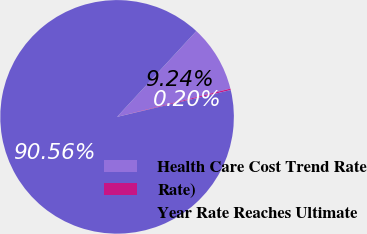Convert chart to OTSL. <chart><loc_0><loc_0><loc_500><loc_500><pie_chart><fcel>Health Care Cost Trend Rate<fcel>Rate)<fcel>Year Rate Reaches Ultimate<nl><fcel>9.24%<fcel>0.2%<fcel>90.56%<nl></chart> 